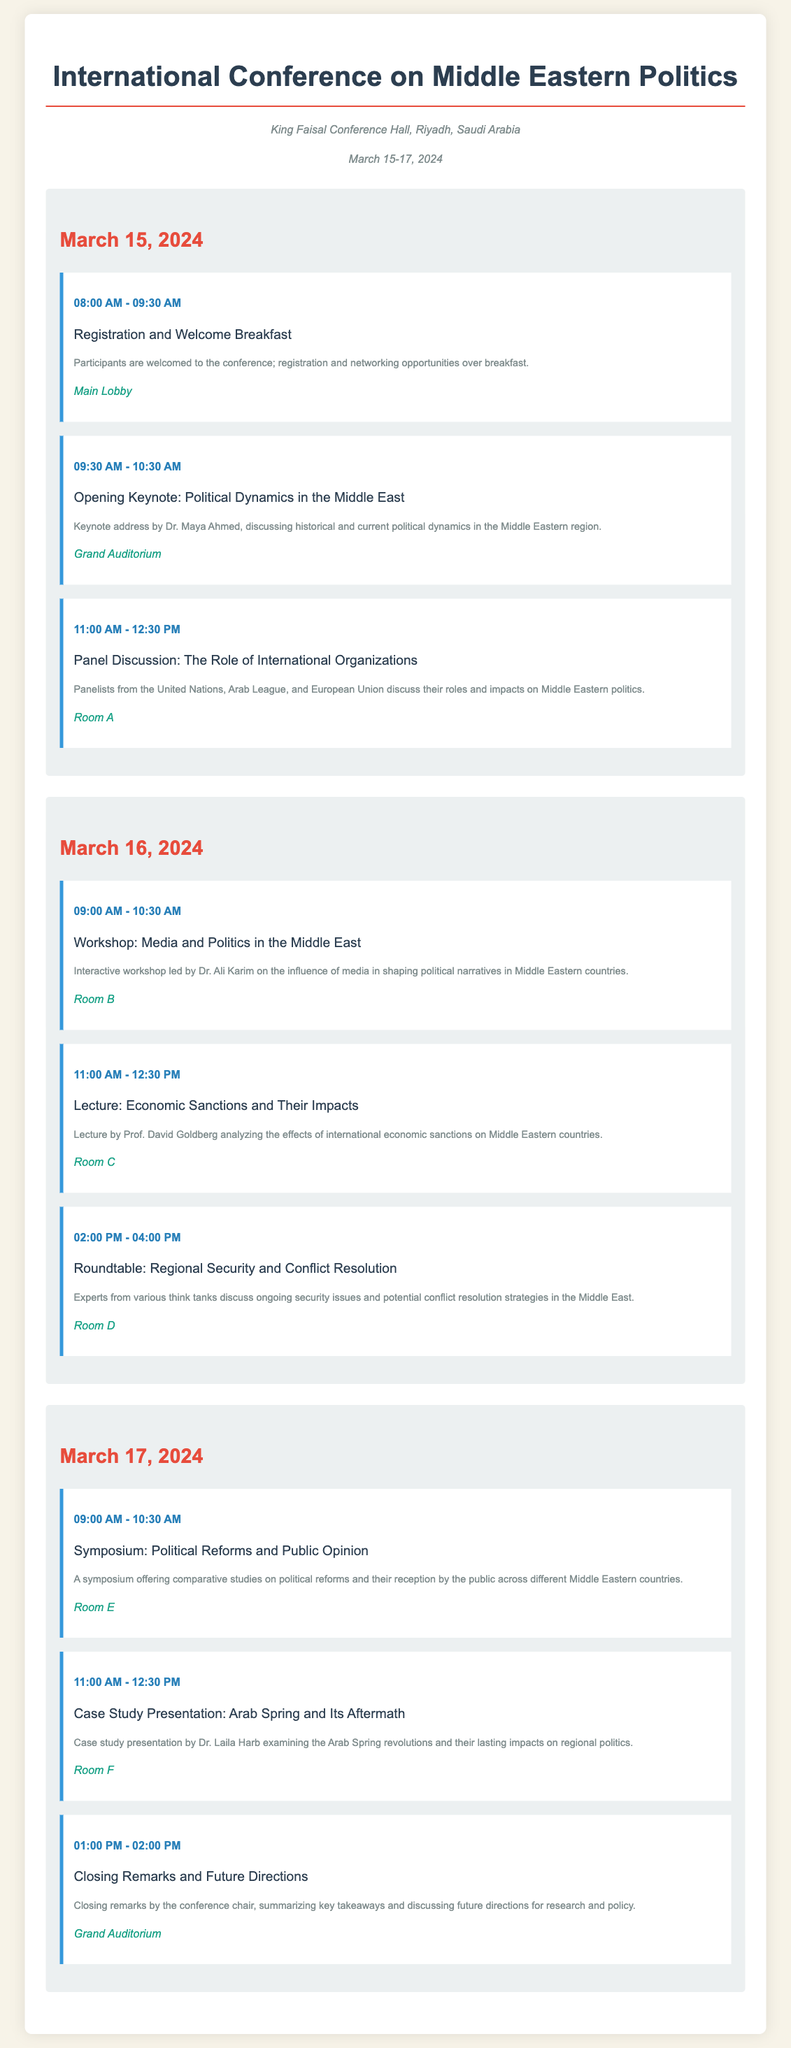What is the location of the conference? The location of the conference is mentioned at the beginning of the document as "King Faisal Conference Hall, Riyadh, Saudi Arabia."
Answer: King Faisal Conference Hall, Riyadh, Saudi Arabia What are the dates of the conference? The document states that the conference will take place from March 15 to March 17, 2024.
Answer: March 15-17, 2024 Who is the keynote speaker on March 15, 2024? The document identifies Dr. Maya Ahmed as the keynote speaker discussing "Political Dynamics in the Middle East."
Answer: Dr. Maya Ahmed What is the allocated time for the Registration and Welcome Breakfast? The document specifies that the Registration and Welcome Breakfast runs from 08:00 AM to 09:30 AM.
Answer: 08:00 AM - 09:30 AM Which room is designated for the Workshop on March 16, 2024? The Workshop on Media and Politics in the Middle East is scheduled to be held in Room B, according to the document.
Answer: Room B How many events are scheduled for March 17, 2024? By counting the events listed for March 17, the document shows there are three events scheduled for that day.
Answer: 3 What is the focus of the Roundtable discussion on March 16, 2024? The topic of the Roundtable is mentioned as "Regional Security and Conflict Resolution," which is explained in the document.
Answer: Regional Security and Conflict Resolution What is the title of the closing session on March 17, 2024? The closing session is titled "Closing Remarks and Future Directions," as indicated in the document.
Answer: Closing Remarks and Future Directions Who presents the case study on the Arab Spring? The document states that Dr. Laila Harb presents the case study on the Arab Spring and its aftermath.
Answer: Dr. Laila Harb 